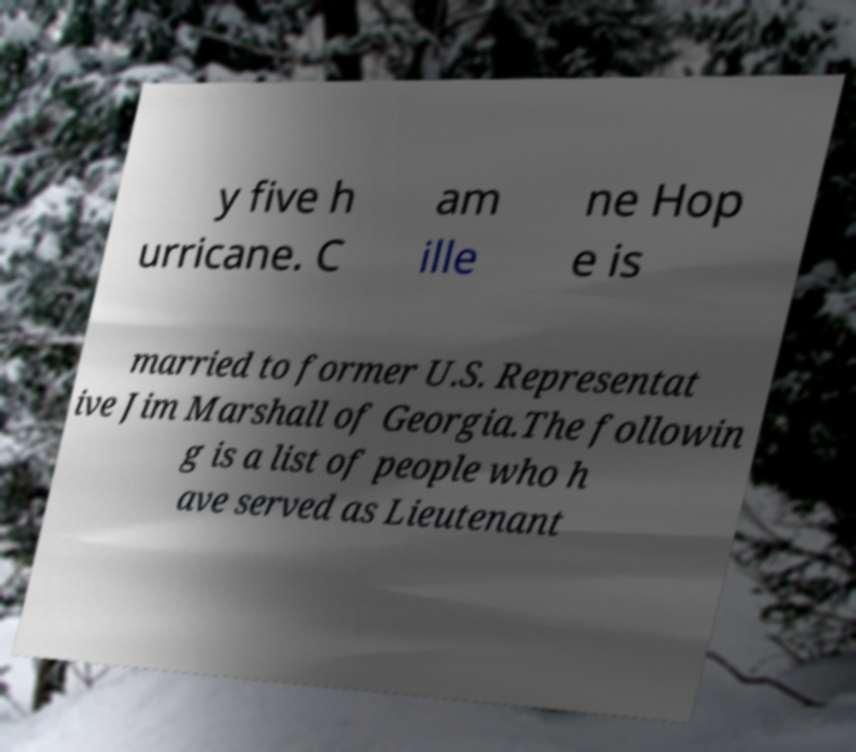Could you extract and type out the text from this image? y five h urricane. C am ille ne Hop e is married to former U.S. Representat ive Jim Marshall of Georgia.The followin g is a list of people who h ave served as Lieutenant 